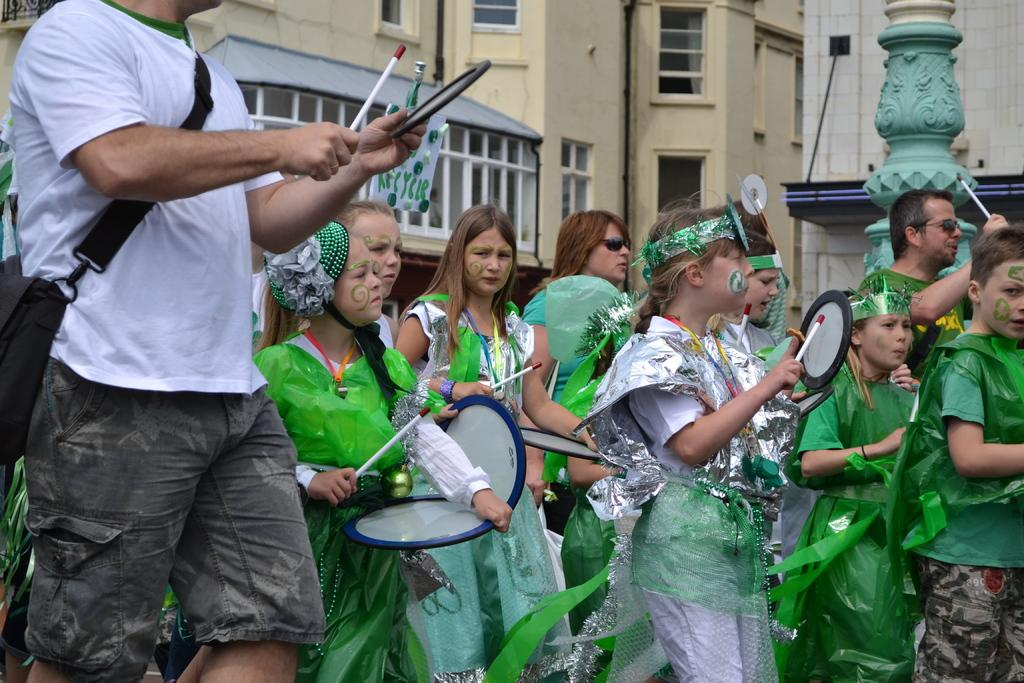What are the people in the image doing? There are people walking on the road in the image. Can you describe the appearance of some of the people in the image? Some of the people are wearing costumes. What are the people in costumes holding? The people in costumes are holding drums. What can be seen in the background of the image? There are buildings in the background of the image. How many clover leaves can be seen in the image? There are no clover leaves present in the image. What type of ear is visible on the people in the image? The image does not show the ears of the people, so it cannot be determined what type of ear they have. 